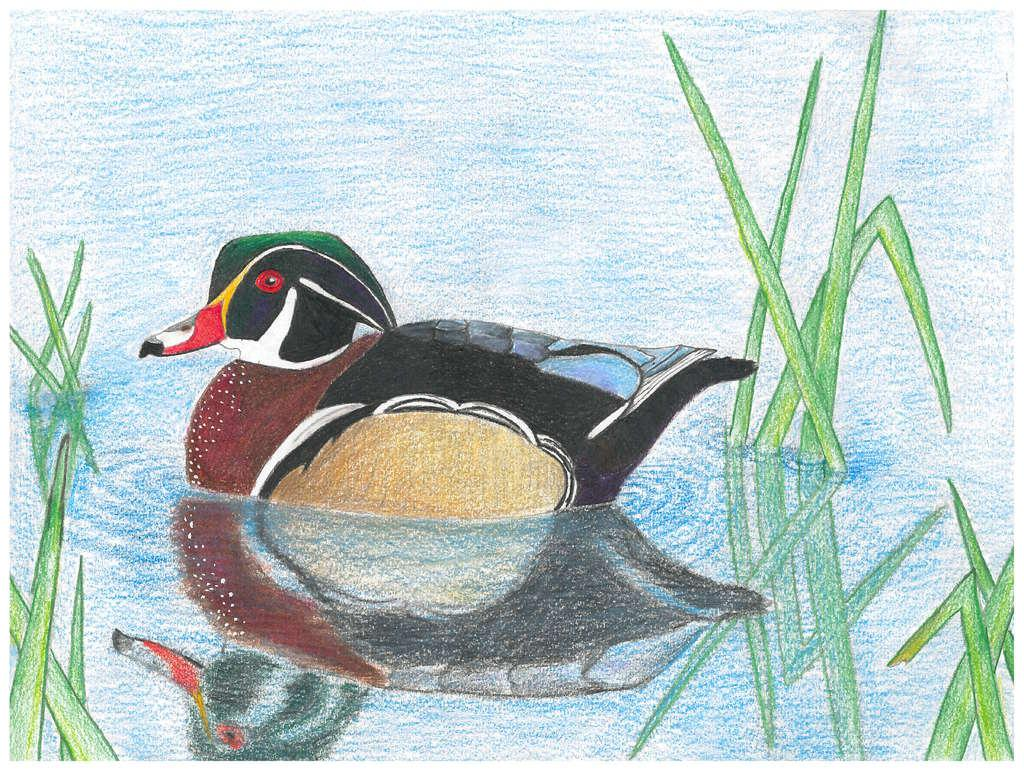What is the main subject of the image? The main subject of the image is a picture. What can be seen in the picture? The picture contains water and a black color duck. Are there any other elements in the water besides the duck? Yes, there is green color grass in the water. What type of pen is the horse using to sign the trade agreement in the image? There is no horse, pen, or trade agreement present in the image. 